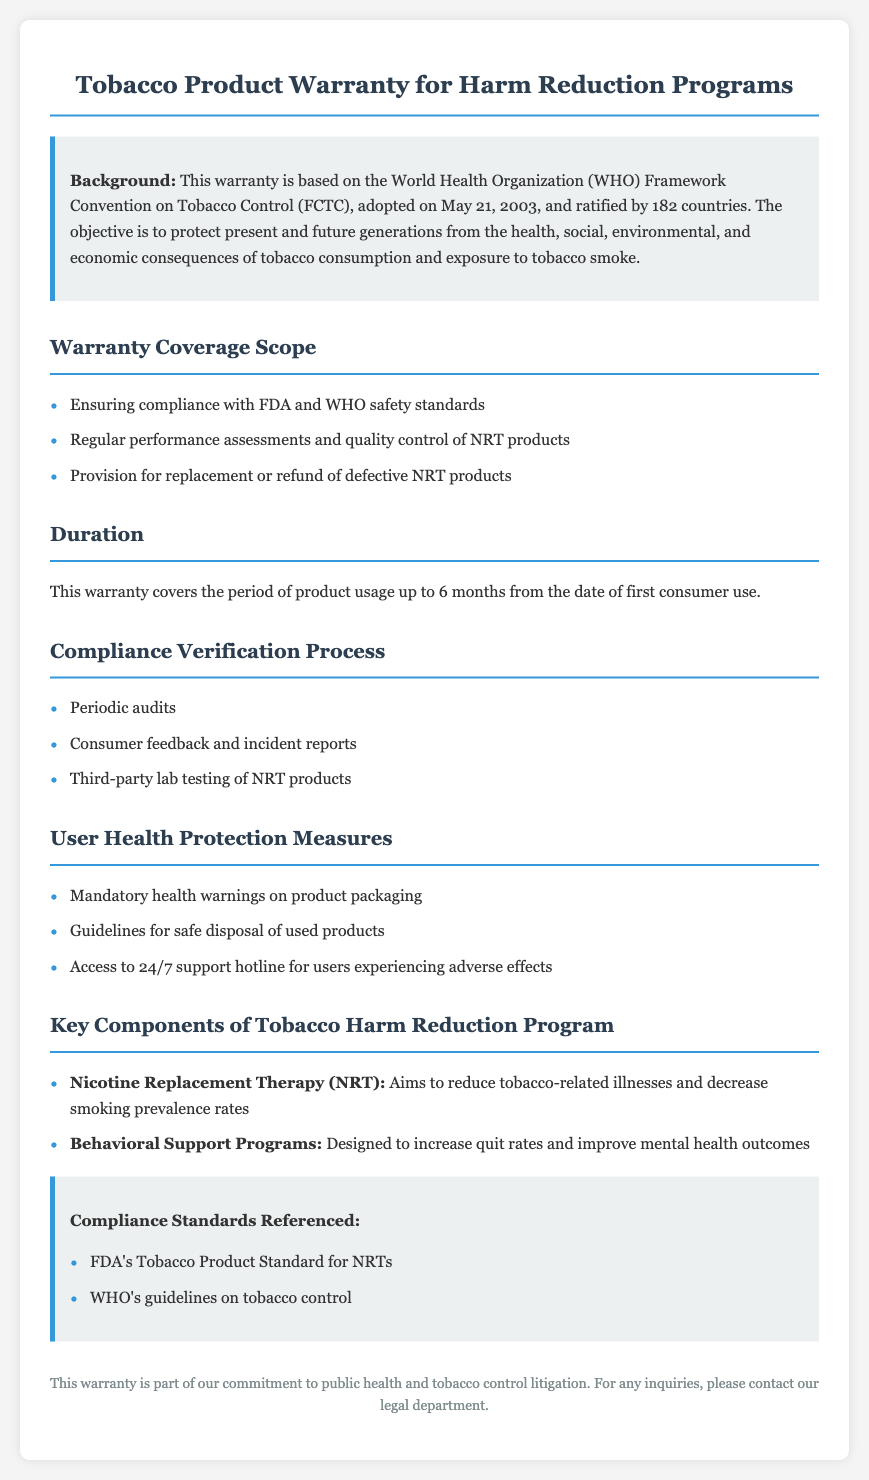What is the duration of the warranty coverage? The duration of the warranty coverage is noted in the document, which specifies the period of product usage covered.
Answer: 6 months What framework does this warranty comply with? The warranty is based on the World Health Organization Framework Convention on Tobacco Control (FCTC), highlighting important compliance.
Answer: FCTC What are the key components of the Tobacco Harm Reduction Program? The document lists significant components such as Nicotine Replacement Therapy and Behavioral Support Programs.
Answer: Nicotine Replacement Therapy, Behavioral Support Programs What compliance standards are referenced in the document? The document includes mentions of specific compliance standards, including those set by the FDA and WHO.
Answer: FDA's Tobacco Product Standard for NRTs, WHO's guidelines on tobacco control What measures are included for user health protection? The document outlines specific user health protection measures such as mandatory health warnings on product packaging.
Answer: Mandatory health warnings on product packaging How are compliance verification processes conducted? The document outlines methods for compliance verification, detailing the types of evaluations that occur.
Answer: Periodic audits, Consumer feedback and incident reports, Third-party lab testing of NRT products What is the purpose of the warranty? The warranty serves a public health goal, ensuring safety standards and protecting user health as stated in the document.
Answer: Protecting user health What type of support is available for users experiencing adverse effects? The document specifies a support hotline for users, which speaks to consumer assistance components in the warranty.
Answer: 24/7 support hotline 